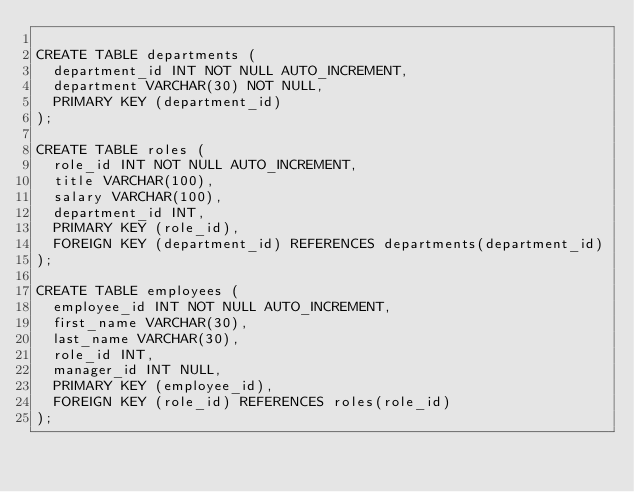<code> <loc_0><loc_0><loc_500><loc_500><_SQL_>
CREATE TABLE departments (
  department_id INT NOT NULL AUTO_INCREMENT,
  department VARCHAR(30) NOT NULL,
  PRIMARY KEY (department_id)
);

CREATE TABLE roles (
  role_id INT NOT NULL AUTO_INCREMENT,
  title VARCHAR(100),
  salary VARCHAR(100),
  department_id INT,
  PRIMARY KEY (role_id),
  FOREIGN KEY (department_id) REFERENCES departments(department_id)
);

CREATE TABLE employees (
  employee_id INT NOT NULL AUTO_INCREMENT,
  first_name VARCHAR(30),
  last_name VARCHAR(30),
  role_id INT,
  manager_id INT NULL,
  PRIMARY KEY (employee_id),
  FOREIGN KEY (role_id) REFERENCES roles(role_id)
);
</code> 